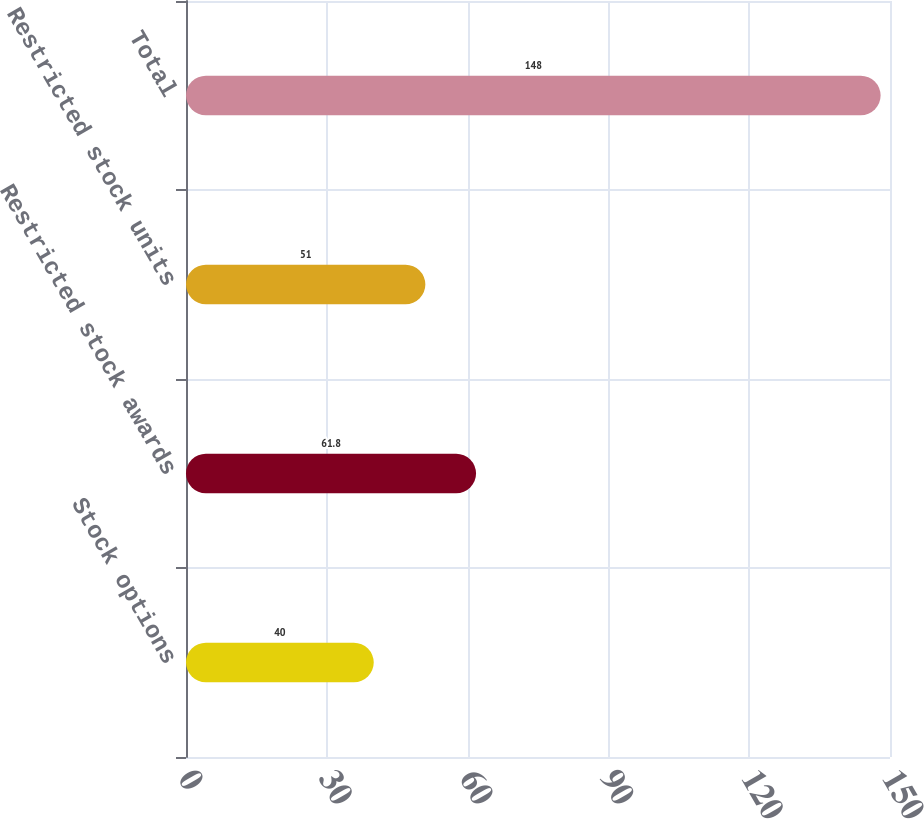Convert chart. <chart><loc_0><loc_0><loc_500><loc_500><bar_chart><fcel>Stock options<fcel>Restricted stock awards<fcel>Restricted stock units<fcel>Total<nl><fcel>40<fcel>61.8<fcel>51<fcel>148<nl></chart> 